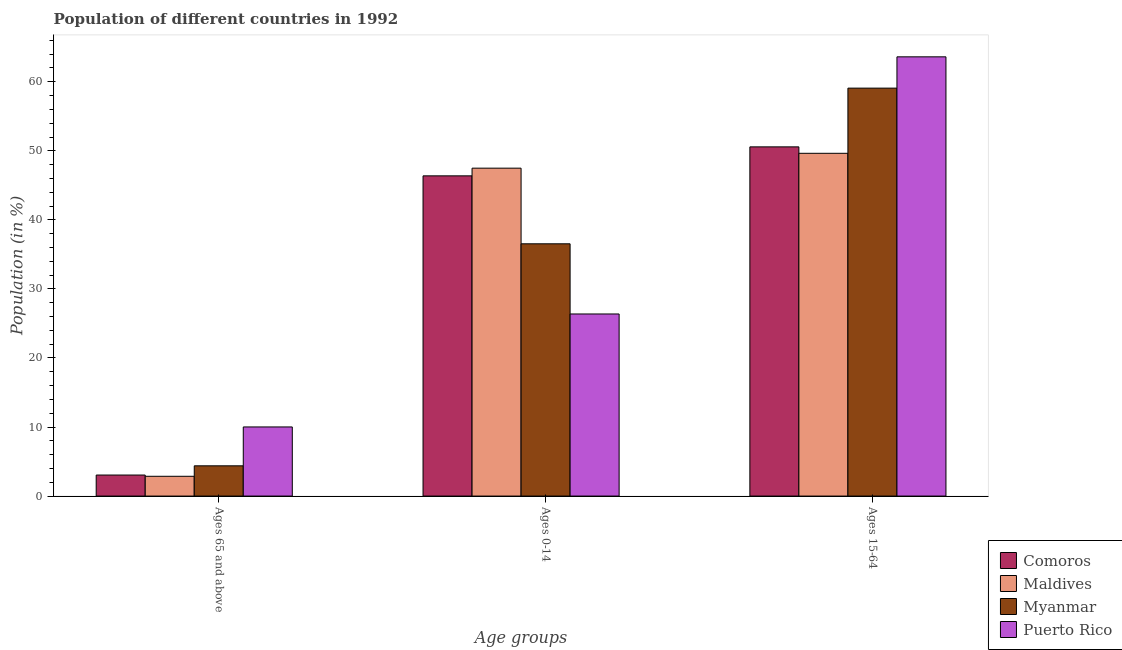How many different coloured bars are there?
Keep it short and to the point. 4. Are the number of bars per tick equal to the number of legend labels?
Give a very brief answer. Yes. How many bars are there on the 2nd tick from the left?
Your response must be concise. 4. How many bars are there on the 3rd tick from the right?
Your response must be concise. 4. What is the label of the 3rd group of bars from the left?
Offer a very short reply. Ages 15-64. What is the percentage of population within the age-group of 65 and above in Myanmar?
Offer a terse response. 4.38. Across all countries, what is the maximum percentage of population within the age-group 0-14?
Your answer should be compact. 47.49. Across all countries, what is the minimum percentage of population within the age-group 0-14?
Provide a short and direct response. 26.37. In which country was the percentage of population within the age-group 15-64 maximum?
Make the answer very short. Puerto Rico. In which country was the percentage of population within the age-group 0-14 minimum?
Make the answer very short. Puerto Rico. What is the total percentage of population within the age-group of 65 and above in the graph?
Ensure brevity in your answer.  20.3. What is the difference between the percentage of population within the age-group of 65 and above in Maldives and that in Comoros?
Offer a terse response. -0.18. What is the difference between the percentage of population within the age-group 0-14 in Comoros and the percentage of population within the age-group of 65 and above in Maldives?
Offer a very short reply. 43.51. What is the average percentage of population within the age-group of 65 and above per country?
Provide a short and direct response. 5.08. What is the difference between the percentage of population within the age-group 15-64 and percentage of population within the age-group of 65 and above in Comoros?
Make the answer very short. 47.53. In how many countries, is the percentage of population within the age-group 15-64 greater than 10 %?
Ensure brevity in your answer.  4. What is the ratio of the percentage of population within the age-group 15-64 in Maldives to that in Puerto Rico?
Your answer should be compact. 0.78. Is the percentage of population within the age-group of 65 and above in Puerto Rico less than that in Comoros?
Make the answer very short. No. Is the difference between the percentage of population within the age-group of 65 and above in Myanmar and Comoros greater than the difference between the percentage of population within the age-group 0-14 in Myanmar and Comoros?
Provide a succinct answer. Yes. What is the difference between the highest and the second highest percentage of population within the age-group of 65 and above?
Offer a terse response. 5.63. What is the difference between the highest and the lowest percentage of population within the age-group of 65 and above?
Provide a succinct answer. 7.15. In how many countries, is the percentage of population within the age-group 0-14 greater than the average percentage of population within the age-group 0-14 taken over all countries?
Your answer should be compact. 2. What does the 4th bar from the left in Ages 15-64 represents?
Give a very brief answer. Puerto Rico. What does the 3rd bar from the right in Ages 65 and above represents?
Your answer should be very brief. Maldives. Is it the case that in every country, the sum of the percentage of population within the age-group of 65 and above and percentage of population within the age-group 0-14 is greater than the percentage of population within the age-group 15-64?
Provide a succinct answer. No. Are the values on the major ticks of Y-axis written in scientific E-notation?
Offer a very short reply. No. Does the graph contain grids?
Your answer should be very brief. No. How are the legend labels stacked?
Your response must be concise. Vertical. What is the title of the graph?
Your response must be concise. Population of different countries in 1992. What is the label or title of the X-axis?
Your response must be concise. Age groups. What is the label or title of the Y-axis?
Keep it short and to the point. Population (in %). What is the Population (in %) in Comoros in Ages 65 and above?
Ensure brevity in your answer.  3.05. What is the Population (in %) of Maldives in Ages 65 and above?
Give a very brief answer. 2.87. What is the Population (in %) of Myanmar in Ages 65 and above?
Your response must be concise. 4.38. What is the Population (in %) of Puerto Rico in Ages 65 and above?
Offer a terse response. 10.01. What is the Population (in %) in Comoros in Ages 0-14?
Give a very brief answer. 46.38. What is the Population (in %) of Maldives in Ages 0-14?
Your response must be concise. 47.49. What is the Population (in %) of Myanmar in Ages 0-14?
Provide a succinct answer. 36.54. What is the Population (in %) in Puerto Rico in Ages 0-14?
Your answer should be compact. 26.37. What is the Population (in %) of Comoros in Ages 15-64?
Make the answer very short. 50.58. What is the Population (in %) of Maldives in Ages 15-64?
Ensure brevity in your answer.  49.64. What is the Population (in %) in Myanmar in Ages 15-64?
Ensure brevity in your answer.  59.08. What is the Population (in %) of Puerto Rico in Ages 15-64?
Give a very brief answer. 63.62. Across all Age groups, what is the maximum Population (in %) of Comoros?
Provide a succinct answer. 50.58. Across all Age groups, what is the maximum Population (in %) in Maldives?
Keep it short and to the point. 49.64. Across all Age groups, what is the maximum Population (in %) in Myanmar?
Your response must be concise. 59.08. Across all Age groups, what is the maximum Population (in %) of Puerto Rico?
Give a very brief answer. 63.62. Across all Age groups, what is the minimum Population (in %) of Comoros?
Make the answer very short. 3.05. Across all Age groups, what is the minimum Population (in %) of Maldives?
Ensure brevity in your answer.  2.87. Across all Age groups, what is the minimum Population (in %) in Myanmar?
Provide a short and direct response. 4.38. Across all Age groups, what is the minimum Population (in %) of Puerto Rico?
Your response must be concise. 10.01. What is the total Population (in %) of Myanmar in the graph?
Provide a short and direct response. 100. What is the total Population (in %) in Puerto Rico in the graph?
Ensure brevity in your answer.  100. What is the difference between the Population (in %) in Comoros in Ages 65 and above and that in Ages 0-14?
Offer a very short reply. -43.33. What is the difference between the Population (in %) of Maldives in Ages 65 and above and that in Ages 0-14?
Give a very brief answer. -44.63. What is the difference between the Population (in %) in Myanmar in Ages 65 and above and that in Ages 0-14?
Provide a short and direct response. -32.16. What is the difference between the Population (in %) of Puerto Rico in Ages 65 and above and that in Ages 0-14?
Provide a short and direct response. -16.36. What is the difference between the Population (in %) of Comoros in Ages 65 and above and that in Ages 15-64?
Offer a very short reply. -47.53. What is the difference between the Population (in %) in Maldives in Ages 65 and above and that in Ages 15-64?
Keep it short and to the point. -46.78. What is the difference between the Population (in %) in Myanmar in Ages 65 and above and that in Ages 15-64?
Your response must be concise. -54.7. What is the difference between the Population (in %) in Puerto Rico in Ages 65 and above and that in Ages 15-64?
Your answer should be very brief. -53.61. What is the difference between the Population (in %) in Comoros in Ages 0-14 and that in Ages 15-64?
Give a very brief answer. -4.2. What is the difference between the Population (in %) of Maldives in Ages 0-14 and that in Ages 15-64?
Ensure brevity in your answer.  -2.15. What is the difference between the Population (in %) of Myanmar in Ages 0-14 and that in Ages 15-64?
Ensure brevity in your answer.  -22.55. What is the difference between the Population (in %) of Puerto Rico in Ages 0-14 and that in Ages 15-64?
Offer a very short reply. -37.24. What is the difference between the Population (in %) in Comoros in Ages 65 and above and the Population (in %) in Maldives in Ages 0-14?
Keep it short and to the point. -44.45. What is the difference between the Population (in %) of Comoros in Ages 65 and above and the Population (in %) of Myanmar in Ages 0-14?
Provide a succinct answer. -33.49. What is the difference between the Population (in %) in Comoros in Ages 65 and above and the Population (in %) in Puerto Rico in Ages 0-14?
Ensure brevity in your answer.  -23.33. What is the difference between the Population (in %) of Maldives in Ages 65 and above and the Population (in %) of Myanmar in Ages 0-14?
Your answer should be compact. -33.67. What is the difference between the Population (in %) of Maldives in Ages 65 and above and the Population (in %) of Puerto Rico in Ages 0-14?
Provide a succinct answer. -23.51. What is the difference between the Population (in %) of Myanmar in Ages 65 and above and the Population (in %) of Puerto Rico in Ages 0-14?
Provide a succinct answer. -21.99. What is the difference between the Population (in %) in Comoros in Ages 65 and above and the Population (in %) in Maldives in Ages 15-64?
Your response must be concise. -46.6. What is the difference between the Population (in %) in Comoros in Ages 65 and above and the Population (in %) in Myanmar in Ages 15-64?
Ensure brevity in your answer.  -56.04. What is the difference between the Population (in %) of Comoros in Ages 65 and above and the Population (in %) of Puerto Rico in Ages 15-64?
Keep it short and to the point. -60.57. What is the difference between the Population (in %) of Maldives in Ages 65 and above and the Population (in %) of Myanmar in Ages 15-64?
Offer a very short reply. -56.22. What is the difference between the Population (in %) in Maldives in Ages 65 and above and the Population (in %) in Puerto Rico in Ages 15-64?
Offer a terse response. -60.75. What is the difference between the Population (in %) in Myanmar in Ages 65 and above and the Population (in %) in Puerto Rico in Ages 15-64?
Provide a succinct answer. -59.24. What is the difference between the Population (in %) in Comoros in Ages 0-14 and the Population (in %) in Maldives in Ages 15-64?
Provide a short and direct response. -3.27. What is the difference between the Population (in %) of Comoros in Ages 0-14 and the Population (in %) of Myanmar in Ages 15-64?
Offer a very short reply. -12.71. What is the difference between the Population (in %) in Comoros in Ages 0-14 and the Population (in %) in Puerto Rico in Ages 15-64?
Ensure brevity in your answer.  -17.24. What is the difference between the Population (in %) in Maldives in Ages 0-14 and the Population (in %) in Myanmar in Ages 15-64?
Provide a succinct answer. -11.59. What is the difference between the Population (in %) of Maldives in Ages 0-14 and the Population (in %) of Puerto Rico in Ages 15-64?
Make the answer very short. -16.13. What is the difference between the Population (in %) in Myanmar in Ages 0-14 and the Population (in %) in Puerto Rico in Ages 15-64?
Your answer should be compact. -27.08. What is the average Population (in %) in Comoros per Age groups?
Ensure brevity in your answer.  33.33. What is the average Population (in %) in Maldives per Age groups?
Ensure brevity in your answer.  33.33. What is the average Population (in %) in Myanmar per Age groups?
Ensure brevity in your answer.  33.33. What is the average Population (in %) of Puerto Rico per Age groups?
Ensure brevity in your answer.  33.33. What is the difference between the Population (in %) of Comoros and Population (in %) of Maldives in Ages 65 and above?
Ensure brevity in your answer.  0.18. What is the difference between the Population (in %) of Comoros and Population (in %) of Myanmar in Ages 65 and above?
Provide a short and direct response. -1.33. What is the difference between the Population (in %) in Comoros and Population (in %) in Puerto Rico in Ages 65 and above?
Your answer should be very brief. -6.97. What is the difference between the Population (in %) of Maldives and Population (in %) of Myanmar in Ages 65 and above?
Give a very brief answer. -1.52. What is the difference between the Population (in %) in Maldives and Population (in %) in Puerto Rico in Ages 65 and above?
Offer a very short reply. -7.15. What is the difference between the Population (in %) in Myanmar and Population (in %) in Puerto Rico in Ages 65 and above?
Your answer should be compact. -5.63. What is the difference between the Population (in %) of Comoros and Population (in %) of Maldives in Ages 0-14?
Your response must be concise. -1.11. What is the difference between the Population (in %) in Comoros and Population (in %) in Myanmar in Ages 0-14?
Your answer should be compact. 9.84. What is the difference between the Population (in %) of Comoros and Population (in %) of Puerto Rico in Ages 0-14?
Your response must be concise. 20.01. What is the difference between the Population (in %) in Maldives and Population (in %) in Myanmar in Ages 0-14?
Provide a short and direct response. 10.96. What is the difference between the Population (in %) of Maldives and Population (in %) of Puerto Rico in Ages 0-14?
Give a very brief answer. 21.12. What is the difference between the Population (in %) in Myanmar and Population (in %) in Puerto Rico in Ages 0-14?
Your response must be concise. 10.16. What is the difference between the Population (in %) of Comoros and Population (in %) of Maldives in Ages 15-64?
Offer a very short reply. 0.93. What is the difference between the Population (in %) of Comoros and Population (in %) of Myanmar in Ages 15-64?
Your answer should be compact. -8.51. What is the difference between the Population (in %) of Comoros and Population (in %) of Puerto Rico in Ages 15-64?
Provide a succinct answer. -13.04. What is the difference between the Population (in %) in Maldives and Population (in %) in Myanmar in Ages 15-64?
Your answer should be compact. -9.44. What is the difference between the Population (in %) of Maldives and Population (in %) of Puerto Rico in Ages 15-64?
Keep it short and to the point. -13.97. What is the difference between the Population (in %) in Myanmar and Population (in %) in Puerto Rico in Ages 15-64?
Make the answer very short. -4.53. What is the ratio of the Population (in %) in Comoros in Ages 65 and above to that in Ages 0-14?
Give a very brief answer. 0.07. What is the ratio of the Population (in %) in Maldives in Ages 65 and above to that in Ages 0-14?
Make the answer very short. 0.06. What is the ratio of the Population (in %) in Myanmar in Ages 65 and above to that in Ages 0-14?
Provide a succinct answer. 0.12. What is the ratio of the Population (in %) of Puerto Rico in Ages 65 and above to that in Ages 0-14?
Your answer should be compact. 0.38. What is the ratio of the Population (in %) in Comoros in Ages 65 and above to that in Ages 15-64?
Ensure brevity in your answer.  0.06. What is the ratio of the Population (in %) of Maldives in Ages 65 and above to that in Ages 15-64?
Ensure brevity in your answer.  0.06. What is the ratio of the Population (in %) in Myanmar in Ages 65 and above to that in Ages 15-64?
Keep it short and to the point. 0.07. What is the ratio of the Population (in %) in Puerto Rico in Ages 65 and above to that in Ages 15-64?
Your answer should be compact. 0.16. What is the ratio of the Population (in %) in Comoros in Ages 0-14 to that in Ages 15-64?
Offer a terse response. 0.92. What is the ratio of the Population (in %) of Maldives in Ages 0-14 to that in Ages 15-64?
Provide a short and direct response. 0.96. What is the ratio of the Population (in %) of Myanmar in Ages 0-14 to that in Ages 15-64?
Make the answer very short. 0.62. What is the ratio of the Population (in %) of Puerto Rico in Ages 0-14 to that in Ages 15-64?
Provide a succinct answer. 0.41. What is the difference between the highest and the second highest Population (in %) of Comoros?
Your response must be concise. 4.2. What is the difference between the highest and the second highest Population (in %) of Maldives?
Your response must be concise. 2.15. What is the difference between the highest and the second highest Population (in %) of Myanmar?
Keep it short and to the point. 22.55. What is the difference between the highest and the second highest Population (in %) in Puerto Rico?
Provide a succinct answer. 37.24. What is the difference between the highest and the lowest Population (in %) in Comoros?
Offer a very short reply. 47.53. What is the difference between the highest and the lowest Population (in %) in Maldives?
Keep it short and to the point. 46.78. What is the difference between the highest and the lowest Population (in %) in Myanmar?
Give a very brief answer. 54.7. What is the difference between the highest and the lowest Population (in %) in Puerto Rico?
Ensure brevity in your answer.  53.61. 